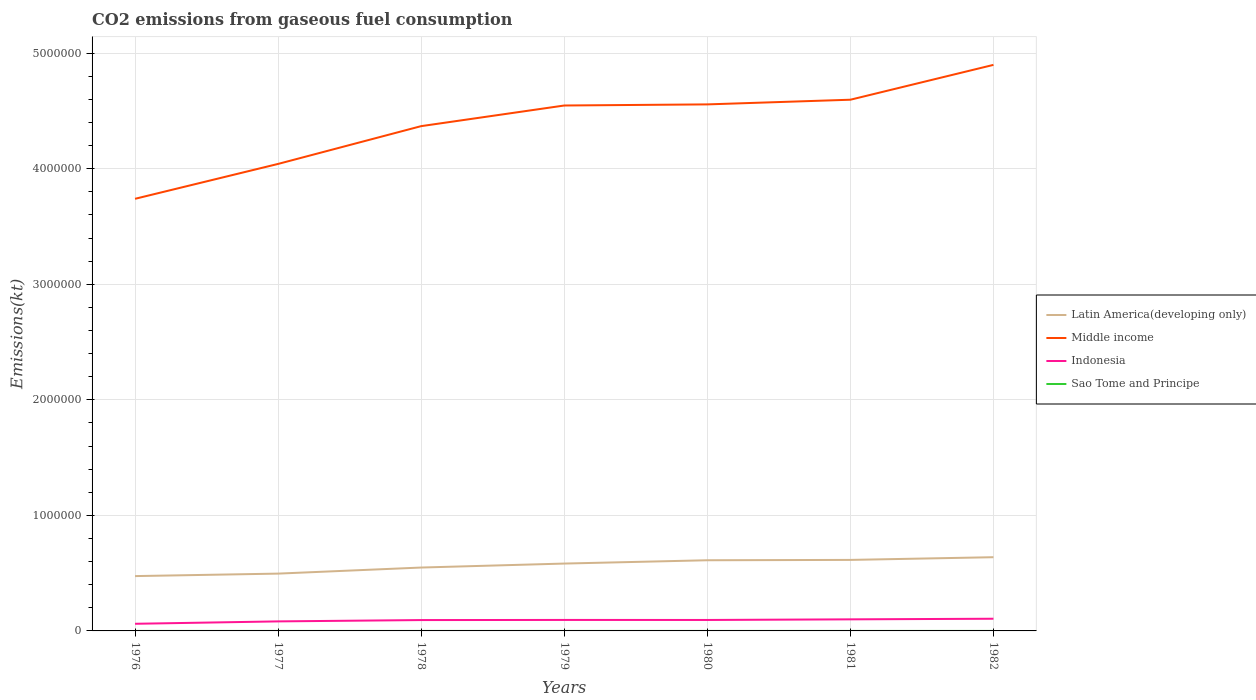How many different coloured lines are there?
Provide a short and direct response. 4. Is the number of lines equal to the number of legend labels?
Provide a succinct answer. Yes. Across all years, what is the maximum amount of CO2 emitted in Sao Tome and Principe?
Your answer should be very brief. 29.34. In which year was the amount of CO2 emitted in Sao Tome and Principe maximum?
Your response must be concise. 1976. What is the total amount of CO2 emitted in Middle income in the graph?
Offer a terse response. -1.16e+06. What is the difference between the highest and the second highest amount of CO2 emitted in Indonesia?
Your response must be concise. 4.36e+04. What is the difference between the highest and the lowest amount of CO2 emitted in Indonesia?
Your answer should be very brief. 5. Is the amount of CO2 emitted in Latin America(developing only) strictly greater than the amount of CO2 emitted in Sao Tome and Principe over the years?
Your answer should be very brief. No. How many lines are there?
Provide a succinct answer. 4. How many years are there in the graph?
Your response must be concise. 7. What is the difference between two consecutive major ticks on the Y-axis?
Make the answer very short. 1.00e+06. Are the values on the major ticks of Y-axis written in scientific E-notation?
Provide a succinct answer. No. Does the graph contain grids?
Keep it short and to the point. Yes. What is the title of the graph?
Offer a very short reply. CO2 emissions from gaseous fuel consumption. Does "Uruguay" appear as one of the legend labels in the graph?
Your response must be concise. No. What is the label or title of the X-axis?
Your answer should be very brief. Years. What is the label or title of the Y-axis?
Provide a short and direct response. Emissions(kt). What is the Emissions(kt) of Latin America(developing only) in 1976?
Provide a short and direct response. 4.74e+05. What is the Emissions(kt) in Middle income in 1976?
Ensure brevity in your answer.  3.74e+06. What is the Emissions(kt) in Indonesia in 1976?
Make the answer very short. 6.18e+04. What is the Emissions(kt) in Sao Tome and Principe in 1976?
Your response must be concise. 29.34. What is the Emissions(kt) of Latin America(developing only) in 1977?
Ensure brevity in your answer.  4.96e+05. What is the Emissions(kt) in Middle income in 1977?
Offer a terse response. 4.04e+06. What is the Emissions(kt) in Indonesia in 1977?
Your answer should be compact. 8.24e+04. What is the Emissions(kt) in Sao Tome and Principe in 1977?
Your answer should be compact. 29.34. What is the Emissions(kt) in Latin America(developing only) in 1978?
Make the answer very short. 5.49e+05. What is the Emissions(kt) of Middle income in 1978?
Keep it short and to the point. 4.37e+06. What is the Emissions(kt) of Indonesia in 1978?
Keep it short and to the point. 9.39e+04. What is the Emissions(kt) of Sao Tome and Principe in 1978?
Your answer should be very brief. 33. What is the Emissions(kt) in Latin America(developing only) in 1979?
Provide a succinct answer. 5.83e+05. What is the Emissions(kt) of Middle income in 1979?
Offer a very short reply. 4.55e+06. What is the Emissions(kt) in Indonesia in 1979?
Provide a short and direct response. 9.51e+04. What is the Emissions(kt) in Sao Tome and Principe in 1979?
Offer a very short reply. 33. What is the Emissions(kt) in Latin America(developing only) in 1980?
Make the answer very short. 6.12e+05. What is the Emissions(kt) of Middle income in 1980?
Offer a terse response. 4.56e+06. What is the Emissions(kt) in Indonesia in 1980?
Ensure brevity in your answer.  9.48e+04. What is the Emissions(kt) in Sao Tome and Principe in 1980?
Provide a succinct answer. 40.34. What is the Emissions(kt) of Latin America(developing only) in 1981?
Provide a succinct answer. 6.15e+05. What is the Emissions(kt) in Middle income in 1981?
Ensure brevity in your answer.  4.60e+06. What is the Emissions(kt) in Indonesia in 1981?
Offer a very short reply. 1.00e+05. What is the Emissions(kt) of Sao Tome and Principe in 1981?
Offer a terse response. 44. What is the Emissions(kt) in Latin America(developing only) in 1982?
Ensure brevity in your answer.  6.38e+05. What is the Emissions(kt) in Middle income in 1982?
Your response must be concise. 4.90e+06. What is the Emissions(kt) of Indonesia in 1982?
Your response must be concise. 1.05e+05. What is the Emissions(kt) of Sao Tome and Principe in 1982?
Keep it short and to the point. 47.67. Across all years, what is the maximum Emissions(kt) in Latin America(developing only)?
Your answer should be very brief. 6.38e+05. Across all years, what is the maximum Emissions(kt) of Middle income?
Ensure brevity in your answer.  4.90e+06. Across all years, what is the maximum Emissions(kt) in Indonesia?
Give a very brief answer. 1.05e+05. Across all years, what is the maximum Emissions(kt) in Sao Tome and Principe?
Offer a very short reply. 47.67. Across all years, what is the minimum Emissions(kt) of Latin America(developing only)?
Offer a very short reply. 4.74e+05. Across all years, what is the minimum Emissions(kt) in Middle income?
Keep it short and to the point. 3.74e+06. Across all years, what is the minimum Emissions(kt) in Indonesia?
Provide a short and direct response. 6.18e+04. Across all years, what is the minimum Emissions(kt) of Sao Tome and Principe?
Keep it short and to the point. 29.34. What is the total Emissions(kt) of Latin America(developing only) in the graph?
Your response must be concise. 3.97e+06. What is the total Emissions(kt) of Middle income in the graph?
Your answer should be very brief. 3.07e+07. What is the total Emissions(kt) in Indonesia in the graph?
Keep it short and to the point. 6.34e+05. What is the total Emissions(kt) of Sao Tome and Principe in the graph?
Make the answer very short. 256.69. What is the difference between the Emissions(kt) of Latin America(developing only) in 1976 and that in 1977?
Ensure brevity in your answer.  -2.16e+04. What is the difference between the Emissions(kt) of Middle income in 1976 and that in 1977?
Offer a terse response. -3.02e+05. What is the difference between the Emissions(kt) in Indonesia in 1976 and that in 1977?
Your answer should be very brief. -2.06e+04. What is the difference between the Emissions(kt) of Latin America(developing only) in 1976 and that in 1978?
Ensure brevity in your answer.  -7.41e+04. What is the difference between the Emissions(kt) of Middle income in 1976 and that in 1978?
Keep it short and to the point. -6.29e+05. What is the difference between the Emissions(kt) of Indonesia in 1976 and that in 1978?
Your answer should be compact. -3.21e+04. What is the difference between the Emissions(kt) in Sao Tome and Principe in 1976 and that in 1978?
Offer a very short reply. -3.67. What is the difference between the Emissions(kt) in Latin America(developing only) in 1976 and that in 1979?
Your response must be concise. -1.09e+05. What is the difference between the Emissions(kt) in Middle income in 1976 and that in 1979?
Your response must be concise. -8.07e+05. What is the difference between the Emissions(kt) in Indonesia in 1976 and that in 1979?
Provide a succinct answer. -3.33e+04. What is the difference between the Emissions(kt) of Sao Tome and Principe in 1976 and that in 1979?
Ensure brevity in your answer.  -3.67. What is the difference between the Emissions(kt) of Latin America(developing only) in 1976 and that in 1980?
Ensure brevity in your answer.  -1.37e+05. What is the difference between the Emissions(kt) of Middle income in 1976 and that in 1980?
Offer a very short reply. -8.17e+05. What is the difference between the Emissions(kt) in Indonesia in 1976 and that in 1980?
Your response must be concise. -3.30e+04. What is the difference between the Emissions(kt) of Sao Tome and Principe in 1976 and that in 1980?
Your response must be concise. -11. What is the difference between the Emissions(kt) in Latin America(developing only) in 1976 and that in 1981?
Keep it short and to the point. -1.40e+05. What is the difference between the Emissions(kt) in Middle income in 1976 and that in 1981?
Offer a terse response. -8.57e+05. What is the difference between the Emissions(kt) in Indonesia in 1976 and that in 1981?
Give a very brief answer. -3.83e+04. What is the difference between the Emissions(kt) in Sao Tome and Principe in 1976 and that in 1981?
Your response must be concise. -14.67. What is the difference between the Emissions(kt) in Latin America(developing only) in 1976 and that in 1982?
Your response must be concise. -1.64e+05. What is the difference between the Emissions(kt) in Middle income in 1976 and that in 1982?
Your response must be concise. -1.16e+06. What is the difference between the Emissions(kt) of Indonesia in 1976 and that in 1982?
Give a very brief answer. -4.36e+04. What is the difference between the Emissions(kt) in Sao Tome and Principe in 1976 and that in 1982?
Your answer should be compact. -18.34. What is the difference between the Emissions(kt) of Latin America(developing only) in 1977 and that in 1978?
Make the answer very short. -5.25e+04. What is the difference between the Emissions(kt) in Middle income in 1977 and that in 1978?
Keep it short and to the point. -3.27e+05. What is the difference between the Emissions(kt) in Indonesia in 1977 and that in 1978?
Offer a terse response. -1.15e+04. What is the difference between the Emissions(kt) in Sao Tome and Principe in 1977 and that in 1978?
Make the answer very short. -3.67. What is the difference between the Emissions(kt) in Latin America(developing only) in 1977 and that in 1979?
Make the answer very short. -8.70e+04. What is the difference between the Emissions(kt) in Middle income in 1977 and that in 1979?
Ensure brevity in your answer.  -5.06e+05. What is the difference between the Emissions(kt) in Indonesia in 1977 and that in 1979?
Give a very brief answer. -1.27e+04. What is the difference between the Emissions(kt) in Sao Tome and Principe in 1977 and that in 1979?
Make the answer very short. -3.67. What is the difference between the Emissions(kt) in Latin America(developing only) in 1977 and that in 1980?
Offer a terse response. -1.16e+05. What is the difference between the Emissions(kt) of Middle income in 1977 and that in 1980?
Provide a succinct answer. -5.15e+05. What is the difference between the Emissions(kt) of Indonesia in 1977 and that in 1980?
Your answer should be very brief. -1.24e+04. What is the difference between the Emissions(kt) of Sao Tome and Principe in 1977 and that in 1980?
Make the answer very short. -11. What is the difference between the Emissions(kt) of Latin America(developing only) in 1977 and that in 1981?
Your answer should be compact. -1.19e+05. What is the difference between the Emissions(kt) in Middle income in 1977 and that in 1981?
Make the answer very short. -5.56e+05. What is the difference between the Emissions(kt) of Indonesia in 1977 and that in 1981?
Offer a terse response. -1.77e+04. What is the difference between the Emissions(kt) of Sao Tome and Principe in 1977 and that in 1981?
Your response must be concise. -14.67. What is the difference between the Emissions(kt) in Latin America(developing only) in 1977 and that in 1982?
Your answer should be compact. -1.42e+05. What is the difference between the Emissions(kt) in Middle income in 1977 and that in 1982?
Ensure brevity in your answer.  -8.57e+05. What is the difference between the Emissions(kt) of Indonesia in 1977 and that in 1982?
Your response must be concise. -2.30e+04. What is the difference between the Emissions(kt) of Sao Tome and Principe in 1977 and that in 1982?
Provide a short and direct response. -18.34. What is the difference between the Emissions(kt) in Latin America(developing only) in 1978 and that in 1979?
Ensure brevity in your answer.  -3.45e+04. What is the difference between the Emissions(kt) of Middle income in 1978 and that in 1979?
Make the answer very short. -1.79e+05. What is the difference between the Emissions(kt) in Indonesia in 1978 and that in 1979?
Provide a succinct answer. -1162.44. What is the difference between the Emissions(kt) of Latin America(developing only) in 1978 and that in 1980?
Offer a very short reply. -6.31e+04. What is the difference between the Emissions(kt) in Middle income in 1978 and that in 1980?
Your response must be concise. -1.88e+05. What is the difference between the Emissions(kt) in Indonesia in 1978 and that in 1980?
Your answer should be very brief. -850.74. What is the difference between the Emissions(kt) in Sao Tome and Principe in 1978 and that in 1980?
Offer a terse response. -7.33. What is the difference between the Emissions(kt) of Latin America(developing only) in 1978 and that in 1981?
Offer a very short reply. -6.60e+04. What is the difference between the Emissions(kt) in Middle income in 1978 and that in 1981?
Offer a very short reply. -2.29e+05. What is the difference between the Emissions(kt) in Indonesia in 1978 and that in 1981?
Your answer should be very brief. -6226.57. What is the difference between the Emissions(kt) of Sao Tome and Principe in 1978 and that in 1981?
Provide a succinct answer. -11. What is the difference between the Emissions(kt) in Latin America(developing only) in 1978 and that in 1982?
Offer a very short reply. -8.94e+04. What is the difference between the Emissions(kt) of Middle income in 1978 and that in 1982?
Your response must be concise. -5.30e+05. What is the difference between the Emissions(kt) in Indonesia in 1978 and that in 1982?
Your answer should be very brief. -1.15e+04. What is the difference between the Emissions(kt) of Sao Tome and Principe in 1978 and that in 1982?
Give a very brief answer. -14.67. What is the difference between the Emissions(kt) in Latin America(developing only) in 1979 and that in 1980?
Keep it short and to the point. -2.86e+04. What is the difference between the Emissions(kt) of Middle income in 1979 and that in 1980?
Give a very brief answer. -9617.95. What is the difference between the Emissions(kt) of Indonesia in 1979 and that in 1980?
Your response must be concise. 311.69. What is the difference between the Emissions(kt) of Sao Tome and Principe in 1979 and that in 1980?
Keep it short and to the point. -7.33. What is the difference between the Emissions(kt) of Latin America(developing only) in 1979 and that in 1981?
Keep it short and to the point. -3.15e+04. What is the difference between the Emissions(kt) in Middle income in 1979 and that in 1981?
Offer a terse response. -5.00e+04. What is the difference between the Emissions(kt) of Indonesia in 1979 and that in 1981?
Give a very brief answer. -5064.13. What is the difference between the Emissions(kt) of Sao Tome and Principe in 1979 and that in 1981?
Your answer should be very brief. -11. What is the difference between the Emissions(kt) of Latin America(developing only) in 1979 and that in 1982?
Make the answer very short. -5.49e+04. What is the difference between the Emissions(kt) in Middle income in 1979 and that in 1982?
Offer a terse response. -3.52e+05. What is the difference between the Emissions(kt) of Indonesia in 1979 and that in 1982?
Offer a very short reply. -1.03e+04. What is the difference between the Emissions(kt) in Sao Tome and Principe in 1979 and that in 1982?
Your answer should be compact. -14.67. What is the difference between the Emissions(kt) of Latin America(developing only) in 1980 and that in 1981?
Your response must be concise. -2893.26. What is the difference between the Emissions(kt) in Middle income in 1980 and that in 1981?
Your answer should be very brief. -4.04e+04. What is the difference between the Emissions(kt) of Indonesia in 1980 and that in 1981?
Provide a short and direct response. -5375.82. What is the difference between the Emissions(kt) of Sao Tome and Principe in 1980 and that in 1981?
Give a very brief answer. -3.67. What is the difference between the Emissions(kt) in Latin America(developing only) in 1980 and that in 1982?
Your answer should be very brief. -2.63e+04. What is the difference between the Emissions(kt) in Middle income in 1980 and that in 1982?
Keep it short and to the point. -3.42e+05. What is the difference between the Emissions(kt) of Indonesia in 1980 and that in 1982?
Ensure brevity in your answer.  -1.06e+04. What is the difference between the Emissions(kt) in Sao Tome and Principe in 1980 and that in 1982?
Provide a short and direct response. -7.33. What is the difference between the Emissions(kt) of Latin America(developing only) in 1981 and that in 1982?
Make the answer very short. -2.34e+04. What is the difference between the Emissions(kt) in Middle income in 1981 and that in 1982?
Your answer should be compact. -3.02e+05. What is the difference between the Emissions(kt) in Indonesia in 1981 and that in 1982?
Give a very brief answer. -5247.48. What is the difference between the Emissions(kt) in Sao Tome and Principe in 1981 and that in 1982?
Provide a succinct answer. -3.67. What is the difference between the Emissions(kt) of Latin America(developing only) in 1976 and the Emissions(kt) of Middle income in 1977?
Make the answer very short. -3.57e+06. What is the difference between the Emissions(kt) of Latin America(developing only) in 1976 and the Emissions(kt) of Indonesia in 1977?
Give a very brief answer. 3.92e+05. What is the difference between the Emissions(kt) in Latin America(developing only) in 1976 and the Emissions(kt) in Sao Tome and Principe in 1977?
Ensure brevity in your answer.  4.74e+05. What is the difference between the Emissions(kt) in Middle income in 1976 and the Emissions(kt) in Indonesia in 1977?
Give a very brief answer. 3.66e+06. What is the difference between the Emissions(kt) in Middle income in 1976 and the Emissions(kt) in Sao Tome and Principe in 1977?
Your answer should be very brief. 3.74e+06. What is the difference between the Emissions(kt) in Indonesia in 1976 and the Emissions(kt) in Sao Tome and Principe in 1977?
Keep it short and to the point. 6.18e+04. What is the difference between the Emissions(kt) in Latin America(developing only) in 1976 and the Emissions(kt) in Middle income in 1978?
Offer a terse response. -3.89e+06. What is the difference between the Emissions(kt) in Latin America(developing only) in 1976 and the Emissions(kt) in Indonesia in 1978?
Give a very brief answer. 3.80e+05. What is the difference between the Emissions(kt) of Latin America(developing only) in 1976 and the Emissions(kt) of Sao Tome and Principe in 1978?
Provide a short and direct response. 4.74e+05. What is the difference between the Emissions(kt) in Middle income in 1976 and the Emissions(kt) in Indonesia in 1978?
Offer a terse response. 3.65e+06. What is the difference between the Emissions(kt) of Middle income in 1976 and the Emissions(kt) of Sao Tome and Principe in 1978?
Offer a terse response. 3.74e+06. What is the difference between the Emissions(kt) in Indonesia in 1976 and the Emissions(kt) in Sao Tome and Principe in 1978?
Keep it short and to the point. 6.18e+04. What is the difference between the Emissions(kt) in Latin America(developing only) in 1976 and the Emissions(kt) in Middle income in 1979?
Give a very brief answer. -4.07e+06. What is the difference between the Emissions(kt) in Latin America(developing only) in 1976 and the Emissions(kt) in Indonesia in 1979?
Offer a very short reply. 3.79e+05. What is the difference between the Emissions(kt) of Latin America(developing only) in 1976 and the Emissions(kt) of Sao Tome and Principe in 1979?
Offer a very short reply. 4.74e+05. What is the difference between the Emissions(kt) of Middle income in 1976 and the Emissions(kt) of Indonesia in 1979?
Provide a succinct answer. 3.64e+06. What is the difference between the Emissions(kt) of Middle income in 1976 and the Emissions(kt) of Sao Tome and Principe in 1979?
Your response must be concise. 3.74e+06. What is the difference between the Emissions(kt) of Indonesia in 1976 and the Emissions(kt) of Sao Tome and Principe in 1979?
Give a very brief answer. 6.18e+04. What is the difference between the Emissions(kt) in Latin America(developing only) in 1976 and the Emissions(kt) in Middle income in 1980?
Provide a short and direct response. -4.08e+06. What is the difference between the Emissions(kt) in Latin America(developing only) in 1976 and the Emissions(kt) in Indonesia in 1980?
Give a very brief answer. 3.80e+05. What is the difference between the Emissions(kt) in Latin America(developing only) in 1976 and the Emissions(kt) in Sao Tome and Principe in 1980?
Your response must be concise. 4.74e+05. What is the difference between the Emissions(kt) of Middle income in 1976 and the Emissions(kt) of Indonesia in 1980?
Make the answer very short. 3.64e+06. What is the difference between the Emissions(kt) in Middle income in 1976 and the Emissions(kt) in Sao Tome and Principe in 1980?
Ensure brevity in your answer.  3.74e+06. What is the difference between the Emissions(kt) in Indonesia in 1976 and the Emissions(kt) in Sao Tome and Principe in 1980?
Provide a succinct answer. 6.18e+04. What is the difference between the Emissions(kt) in Latin America(developing only) in 1976 and the Emissions(kt) in Middle income in 1981?
Offer a very short reply. -4.12e+06. What is the difference between the Emissions(kt) of Latin America(developing only) in 1976 and the Emissions(kt) of Indonesia in 1981?
Provide a succinct answer. 3.74e+05. What is the difference between the Emissions(kt) of Latin America(developing only) in 1976 and the Emissions(kt) of Sao Tome and Principe in 1981?
Ensure brevity in your answer.  4.74e+05. What is the difference between the Emissions(kt) in Middle income in 1976 and the Emissions(kt) in Indonesia in 1981?
Keep it short and to the point. 3.64e+06. What is the difference between the Emissions(kt) of Middle income in 1976 and the Emissions(kt) of Sao Tome and Principe in 1981?
Your response must be concise. 3.74e+06. What is the difference between the Emissions(kt) in Indonesia in 1976 and the Emissions(kt) in Sao Tome and Principe in 1981?
Offer a very short reply. 6.18e+04. What is the difference between the Emissions(kt) in Latin America(developing only) in 1976 and the Emissions(kt) in Middle income in 1982?
Keep it short and to the point. -4.42e+06. What is the difference between the Emissions(kt) of Latin America(developing only) in 1976 and the Emissions(kt) of Indonesia in 1982?
Ensure brevity in your answer.  3.69e+05. What is the difference between the Emissions(kt) of Latin America(developing only) in 1976 and the Emissions(kt) of Sao Tome and Principe in 1982?
Give a very brief answer. 4.74e+05. What is the difference between the Emissions(kt) in Middle income in 1976 and the Emissions(kt) in Indonesia in 1982?
Your answer should be very brief. 3.63e+06. What is the difference between the Emissions(kt) in Middle income in 1976 and the Emissions(kt) in Sao Tome and Principe in 1982?
Provide a short and direct response. 3.74e+06. What is the difference between the Emissions(kt) of Indonesia in 1976 and the Emissions(kt) of Sao Tome and Principe in 1982?
Offer a terse response. 6.18e+04. What is the difference between the Emissions(kt) of Latin America(developing only) in 1977 and the Emissions(kt) of Middle income in 1978?
Your answer should be very brief. -3.87e+06. What is the difference between the Emissions(kt) in Latin America(developing only) in 1977 and the Emissions(kt) in Indonesia in 1978?
Keep it short and to the point. 4.02e+05. What is the difference between the Emissions(kt) in Latin America(developing only) in 1977 and the Emissions(kt) in Sao Tome and Principe in 1978?
Your response must be concise. 4.96e+05. What is the difference between the Emissions(kt) of Middle income in 1977 and the Emissions(kt) of Indonesia in 1978?
Offer a terse response. 3.95e+06. What is the difference between the Emissions(kt) in Middle income in 1977 and the Emissions(kt) in Sao Tome and Principe in 1978?
Give a very brief answer. 4.04e+06. What is the difference between the Emissions(kt) in Indonesia in 1977 and the Emissions(kt) in Sao Tome and Principe in 1978?
Your answer should be compact. 8.24e+04. What is the difference between the Emissions(kt) of Latin America(developing only) in 1977 and the Emissions(kt) of Middle income in 1979?
Ensure brevity in your answer.  -4.05e+06. What is the difference between the Emissions(kt) in Latin America(developing only) in 1977 and the Emissions(kt) in Indonesia in 1979?
Offer a very short reply. 4.01e+05. What is the difference between the Emissions(kt) of Latin America(developing only) in 1977 and the Emissions(kt) of Sao Tome and Principe in 1979?
Your answer should be compact. 4.96e+05. What is the difference between the Emissions(kt) of Middle income in 1977 and the Emissions(kt) of Indonesia in 1979?
Make the answer very short. 3.95e+06. What is the difference between the Emissions(kt) of Middle income in 1977 and the Emissions(kt) of Sao Tome and Principe in 1979?
Your answer should be compact. 4.04e+06. What is the difference between the Emissions(kt) in Indonesia in 1977 and the Emissions(kt) in Sao Tome and Principe in 1979?
Your response must be concise. 8.24e+04. What is the difference between the Emissions(kt) of Latin America(developing only) in 1977 and the Emissions(kt) of Middle income in 1980?
Your answer should be compact. -4.06e+06. What is the difference between the Emissions(kt) of Latin America(developing only) in 1977 and the Emissions(kt) of Indonesia in 1980?
Your response must be concise. 4.01e+05. What is the difference between the Emissions(kt) of Latin America(developing only) in 1977 and the Emissions(kt) of Sao Tome and Principe in 1980?
Give a very brief answer. 4.96e+05. What is the difference between the Emissions(kt) in Middle income in 1977 and the Emissions(kt) in Indonesia in 1980?
Provide a short and direct response. 3.95e+06. What is the difference between the Emissions(kt) of Middle income in 1977 and the Emissions(kt) of Sao Tome and Principe in 1980?
Provide a short and direct response. 4.04e+06. What is the difference between the Emissions(kt) of Indonesia in 1977 and the Emissions(kt) of Sao Tome and Principe in 1980?
Ensure brevity in your answer.  8.24e+04. What is the difference between the Emissions(kt) of Latin America(developing only) in 1977 and the Emissions(kt) of Middle income in 1981?
Provide a short and direct response. -4.10e+06. What is the difference between the Emissions(kt) of Latin America(developing only) in 1977 and the Emissions(kt) of Indonesia in 1981?
Your answer should be compact. 3.96e+05. What is the difference between the Emissions(kt) of Latin America(developing only) in 1977 and the Emissions(kt) of Sao Tome and Principe in 1981?
Give a very brief answer. 4.96e+05. What is the difference between the Emissions(kt) of Middle income in 1977 and the Emissions(kt) of Indonesia in 1981?
Offer a terse response. 3.94e+06. What is the difference between the Emissions(kt) of Middle income in 1977 and the Emissions(kt) of Sao Tome and Principe in 1981?
Provide a succinct answer. 4.04e+06. What is the difference between the Emissions(kt) in Indonesia in 1977 and the Emissions(kt) in Sao Tome and Principe in 1981?
Provide a succinct answer. 8.24e+04. What is the difference between the Emissions(kt) of Latin America(developing only) in 1977 and the Emissions(kt) of Middle income in 1982?
Provide a succinct answer. -4.40e+06. What is the difference between the Emissions(kt) of Latin America(developing only) in 1977 and the Emissions(kt) of Indonesia in 1982?
Offer a terse response. 3.91e+05. What is the difference between the Emissions(kt) of Latin America(developing only) in 1977 and the Emissions(kt) of Sao Tome and Principe in 1982?
Make the answer very short. 4.96e+05. What is the difference between the Emissions(kt) in Middle income in 1977 and the Emissions(kt) in Indonesia in 1982?
Your answer should be compact. 3.94e+06. What is the difference between the Emissions(kt) of Middle income in 1977 and the Emissions(kt) of Sao Tome and Principe in 1982?
Your response must be concise. 4.04e+06. What is the difference between the Emissions(kt) of Indonesia in 1977 and the Emissions(kt) of Sao Tome and Principe in 1982?
Offer a very short reply. 8.24e+04. What is the difference between the Emissions(kt) of Latin America(developing only) in 1978 and the Emissions(kt) of Middle income in 1979?
Keep it short and to the point. -4.00e+06. What is the difference between the Emissions(kt) of Latin America(developing only) in 1978 and the Emissions(kt) of Indonesia in 1979?
Your answer should be very brief. 4.53e+05. What is the difference between the Emissions(kt) in Latin America(developing only) in 1978 and the Emissions(kt) in Sao Tome and Principe in 1979?
Give a very brief answer. 5.48e+05. What is the difference between the Emissions(kt) in Middle income in 1978 and the Emissions(kt) in Indonesia in 1979?
Ensure brevity in your answer.  4.27e+06. What is the difference between the Emissions(kt) in Middle income in 1978 and the Emissions(kt) in Sao Tome and Principe in 1979?
Offer a very short reply. 4.37e+06. What is the difference between the Emissions(kt) in Indonesia in 1978 and the Emissions(kt) in Sao Tome and Principe in 1979?
Ensure brevity in your answer.  9.39e+04. What is the difference between the Emissions(kt) in Latin America(developing only) in 1978 and the Emissions(kt) in Middle income in 1980?
Give a very brief answer. -4.01e+06. What is the difference between the Emissions(kt) in Latin America(developing only) in 1978 and the Emissions(kt) in Indonesia in 1980?
Your answer should be compact. 4.54e+05. What is the difference between the Emissions(kt) of Latin America(developing only) in 1978 and the Emissions(kt) of Sao Tome and Principe in 1980?
Offer a very short reply. 5.48e+05. What is the difference between the Emissions(kt) in Middle income in 1978 and the Emissions(kt) in Indonesia in 1980?
Make the answer very short. 4.27e+06. What is the difference between the Emissions(kt) of Middle income in 1978 and the Emissions(kt) of Sao Tome and Principe in 1980?
Your answer should be compact. 4.37e+06. What is the difference between the Emissions(kt) of Indonesia in 1978 and the Emissions(kt) of Sao Tome and Principe in 1980?
Your response must be concise. 9.39e+04. What is the difference between the Emissions(kt) of Latin America(developing only) in 1978 and the Emissions(kt) of Middle income in 1981?
Offer a very short reply. -4.05e+06. What is the difference between the Emissions(kt) in Latin America(developing only) in 1978 and the Emissions(kt) in Indonesia in 1981?
Provide a succinct answer. 4.48e+05. What is the difference between the Emissions(kt) in Latin America(developing only) in 1978 and the Emissions(kt) in Sao Tome and Principe in 1981?
Provide a succinct answer. 5.48e+05. What is the difference between the Emissions(kt) in Middle income in 1978 and the Emissions(kt) in Indonesia in 1981?
Make the answer very short. 4.27e+06. What is the difference between the Emissions(kt) in Middle income in 1978 and the Emissions(kt) in Sao Tome and Principe in 1981?
Your response must be concise. 4.37e+06. What is the difference between the Emissions(kt) of Indonesia in 1978 and the Emissions(kt) of Sao Tome and Principe in 1981?
Make the answer very short. 9.39e+04. What is the difference between the Emissions(kt) in Latin America(developing only) in 1978 and the Emissions(kt) in Middle income in 1982?
Give a very brief answer. -4.35e+06. What is the difference between the Emissions(kt) in Latin America(developing only) in 1978 and the Emissions(kt) in Indonesia in 1982?
Make the answer very short. 4.43e+05. What is the difference between the Emissions(kt) in Latin America(developing only) in 1978 and the Emissions(kt) in Sao Tome and Principe in 1982?
Your answer should be compact. 5.48e+05. What is the difference between the Emissions(kt) in Middle income in 1978 and the Emissions(kt) in Indonesia in 1982?
Keep it short and to the point. 4.26e+06. What is the difference between the Emissions(kt) in Middle income in 1978 and the Emissions(kt) in Sao Tome and Principe in 1982?
Make the answer very short. 4.37e+06. What is the difference between the Emissions(kt) in Indonesia in 1978 and the Emissions(kt) in Sao Tome and Principe in 1982?
Your response must be concise. 9.39e+04. What is the difference between the Emissions(kt) of Latin America(developing only) in 1979 and the Emissions(kt) of Middle income in 1980?
Ensure brevity in your answer.  -3.97e+06. What is the difference between the Emissions(kt) of Latin America(developing only) in 1979 and the Emissions(kt) of Indonesia in 1980?
Your response must be concise. 4.88e+05. What is the difference between the Emissions(kt) in Latin America(developing only) in 1979 and the Emissions(kt) in Sao Tome and Principe in 1980?
Ensure brevity in your answer.  5.83e+05. What is the difference between the Emissions(kt) of Middle income in 1979 and the Emissions(kt) of Indonesia in 1980?
Provide a succinct answer. 4.45e+06. What is the difference between the Emissions(kt) in Middle income in 1979 and the Emissions(kt) in Sao Tome and Principe in 1980?
Make the answer very short. 4.55e+06. What is the difference between the Emissions(kt) of Indonesia in 1979 and the Emissions(kt) of Sao Tome and Principe in 1980?
Ensure brevity in your answer.  9.51e+04. What is the difference between the Emissions(kt) in Latin America(developing only) in 1979 and the Emissions(kt) in Middle income in 1981?
Your response must be concise. -4.01e+06. What is the difference between the Emissions(kt) of Latin America(developing only) in 1979 and the Emissions(kt) of Indonesia in 1981?
Your answer should be compact. 4.83e+05. What is the difference between the Emissions(kt) of Latin America(developing only) in 1979 and the Emissions(kt) of Sao Tome and Principe in 1981?
Your answer should be compact. 5.83e+05. What is the difference between the Emissions(kt) of Middle income in 1979 and the Emissions(kt) of Indonesia in 1981?
Your answer should be compact. 4.45e+06. What is the difference between the Emissions(kt) in Middle income in 1979 and the Emissions(kt) in Sao Tome and Principe in 1981?
Give a very brief answer. 4.55e+06. What is the difference between the Emissions(kt) of Indonesia in 1979 and the Emissions(kt) of Sao Tome and Principe in 1981?
Give a very brief answer. 9.51e+04. What is the difference between the Emissions(kt) in Latin America(developing only) in 1979 and the Emissions(kt) in Middle income in 1982?
Your answer should be compact. -4.32e+06. What is the difference between the Emissions(kt) in Latin America(developing only) in 1979 and the Emissions(kt) in Indonesia in 1982?
Offer a terse response. 4.78e+05. What is the difference between the Emissions(kt) in Latin America(developing only) in 1979 and the Emissions(kt) in Sao Tome and Principe in 1982?
Your answer should be very brief. 5.83e+05. What is the difference between the Emissions(kt) in Middle income in 1979 and the Emissions(kt) in Indonesia in 1982?
Your answer should be compact. 4.44e+06. What is the difference between the Emissions(kt) in Middle income in 1979 and the Emissions(kt) in Sao Tome and Principe in 1982?
Provide a succinct answer. 4.55e+06. What is the difference between the Emissions(kt) of Indonesia in 1979 and the Emissions(kt) of Sao Tome and Principe in 1982?
Your response must be concise. 9.50e+04. What is the difference between the Emissions(kt) of Latin America(developing only) in 1980 and the Emissions(kt) of Middle income in 1981?
Your answer should be very brief. -3.99e+06. What is the difference between the Emissions(kt) in Latin America(developing only) in 1980 and the Emissions(kt) in Indonesia in 1981?
Your response must be concise. 5.11e+05. What is the difference between the Emissions(kt) in Latin America(developing only) in 1980 and the Emissions(kt) in Sao Tome and Principe in 1981?
Offer a very short reply. 6.12e+05. What is the difference between the Emissions(kt) of Middle income in 1980 and the Emissions(kt) of Indonesia in 1981?
Provide a short and direct response. 4.46e+06. What is the difference between the Emissions(kt) of Middle income in 1980 and the Emissions(kt) of Sao Tome and Principe in 1981?
Make the answer very short. 4.56e+06. What is the difference between the Emissions(kt) of Indonesia in 1980 and the Emissions(kt) of Sao Tome and Principe in 1981?
Provide a succinct answer. 9.47e+04. What is the difference between the Emissions(kt) in Latin America(developing only) in 1980 and the Emissions(kt) in Middle income in 1982?
Provide a short and direct response. -4.29e+06. What is the difference between the Emissions(kt) of Latin America(developing only) in 1980 and the Emissions(kt) of Indonesia in 1982?
Offer a very short reply. 5.06e+05. What is the difference between the Emissions(kt) of Latin America(developing only) in 1980 and the Emissions(kt) of Sao Tome and Principe in 1982?
Offer a terse response. 6.12e+05. What is the difference between the Emissions(kt) of Middle income in 1980 and the Emissions(kt) of Indonesia in 1982?
Ensure brevity in your answer.  4.45e+06. What is the difference between the Emissions(kt) in Middle income in 1980 and the Emissions(kt) in Sao Tome and Principe in 1982?
Offer a very short reply. 4.56e+06. What is the difference between the Emissions(kt) of Indonesia in 1980 and the Emissions(kt) of Sao Tome and Principe in 1982?
Your answer should be very brief. 9.47e+04. What is the difference between the Emissions(kt) of Latin America(developing only) in 1981 and the Emissions(kt) of Middle income in 1982?
Keep it short and to the point. -4.28e+06. What is the difference between the Emissions(kt) in Latin America(developing only) in 1981 and the Emissions(kt) in Indonesia in 1982?
Make the answer very short. 5.09e+05. What is the difference between the Emissions(kt) in Latin America(developing only) in 1981 and the Emissions(kt) in Sao Tome and Principe in 1982?
Ensure brevity in your answer.  6.14e+05. What is the difference between the Emissions(kt) in Middle income in 1981 and the Emissions(kt) in Indonesia in 1982?
Provide a succinct answer. 4.49e+06. What is the difference between the Emissions(kt) of Middle income in 1981 and the Emissions(kt) of Sao Tome and Principe in 1982?
Offer a very short reply. 4.60e+06. What is the difference between the Emissions(kt) of Indonesia in 1981 and the Emissions(kt) of Sao Tome and Principe in 1982?
Provide a short and direct response. 1.00e+05. What is the average Emissions(kt) of Latin America(developing only) per year?
Your answer should be very brief. 5.67e+05. What is the average Emissions(kt) in Middle income per year?
Give a very brief answer. 4.39e+06. What is the average Emissions(kt) in Indonesia per year?
Offer a very short reply. 9.05e+04. What is the average Emissions(kt) of Sao Tome and Principe per year?
Offer a very short reply. 36.67. In the year 1976, what is the difference between the Emissions(kt) in Latin America(developing only) and Emissions(kt) in Middle income?
Your response must be concise. -3.27e+06. In the year 1976, what is the difference between the Emissions(kt) in Latin America(developing only) and Emissions(kt) in Indonesia?
Provide a succinct answer. 4.13e+05. In the year 1976, what is the difference between the Emissions(kt) in Latin America(developing only) and Emissions(kt) in Sao Tome and Principe?
Provide a short and direct response. 4.74e+05. In the year 1976, what is the difference between the Emissions(kt) in Middle income and Emissions(kt) in Indonesia?
Provide a short and direct response. 3.68e+06. In the year 1976, what is the difference between the Emissions(kt) in Middle income and Emissions(kt) in Sao Tome and Principe?
Provide a short and direct response. 3.74e+06. In the year 1976, what is the difference between the Emissions(kt) of Indonesia and Emissions(kt) of Sao Tome and Principe?
Provide a succinct answer. 6.18e+04. In the year 1977, what is the difference between the Emissions(kt) in Latin America(developing only) and Emissions(kt) in Middle income?
Ensure brevity in your answer.  -3.55e+06. In the year 1977, what is the difference between the Emissions(kt) in Latin America(developing only) and Emissions(kt) in Indonesia?
Ensure brevity in your answer.  4.14e+05. In the year 1977, what is the difference between the Emissions(kt) in Latin America(developing only) and Emissions(kt) in Sao Tome and Principe?
Keep it short and to the point. 4.96e+05. In the year 1977, what is the difference between the Emissions(kt) in Middle income and Emissions(kt) in Indonesia?
Give a very brief answer. 3.96e+06. In the year 1977, what is the difference between the Emissions(kt) of Middle income and Emissions(kt) of Sao Tome and Principe?
Provide a short and direct response. 4.04e+06. In the year 1977, what is the difference between the Emissions(kt) in Indonesia and Emissions(kt) in Sao Tome and Principe?
Keep it short and to the point. 8.24e+04. In the year 1978, what is the difference between the Emissions(kt) in Latin America(developing only) and Emissions(kt) in Middle income?
Provide a succinct answer. -3.82e+06. In the year 1978, what is the difference between the Emissions(kt) of Latin America(developing only) and Emissions(kt) of Indonesia?
Your answer should be compact. 4.55e+05. In the year 1978, what is the difference between the Emissions(kt) of Latin America(developing only) and Emissions(kt) of Sao Tome and Principe?
Ensure brevity in your answer.  5.48e+05. In the year 1978, what is the difference between the Emissions(kt) in Middle income and Emissions(kt) in Indonesia?
Offer a terse response. 4.27e+06. In the year 1978, what is the difference between the Emissions(kt) of Middle income and Emissions(kt) of Sao Tome and Principe?
Provide a succinct answer. 4.37e+06. In the year 1978, what is the difference between the Emissions(kt) in Indonesia and Emissions(kt) in Sao Tome and Principe?
Provide a short and direct response. 9.39e+04. In the year 1979, what is the difference between the Emissions(kt) of Latin America(developing only) and Emissions(kt) of Middle income?
Provide a succinct answer. -3.96e+06. In the year 1979, what is the difference between the Emissions(kt) of Latin America(developing only) and Emissions(kt) of Indonesia?
Keep it short and to the point. 4.88e+05. In the year 1979, what is the difference between the Emissions(kt) in Latin America(developing only) and Emissions(kt) in Sao Tome and Principe?
Ensure brevity in your answer.  5.83e+05. In the year 1979, what is the difference between the Emissions(kt) in Middle income and Emissions(kt) in Indonesia?
Provide a short and direct response. 4.45e+06. In the year 1979, what is the difference between the Emissions(kt) of Middle income and Emissions(kt) of Sao Tome and Principe?
Your answer should be very brief. 4.55e+06. In the year 1979, what is the difference between the Emissions(kt) in Indonesia and Emissions(kt) in Sao Tome and Principe?
Provide a succinct answer. 9.51e+04. In the year 1980, what is the difference between the Emissions(kt) of Latin America(developing only) and Emissions(kt) of Middle income?
Ensure brevity in your answer.  -3.95e+06. In the year 1980, what is the difference between the Emissions(kt) in Latin America(developing only) and Emissions(kt) in Indonesia?
Offer a very short reply. 5.17e+05. In the year 1980, what is the difference between the Emissions(kt) in Latin America(developing only) and Emissions(kt) in Sao Tome and Principe?
Give a very brief answer. 6.12e+05. In the year 1980, what is the difference between the Emissions(kt) in Middle income and Emissions(kt) in Indonesia?
Ensure brevity in your answer.  4.46e+06. In the year 1980, what is the difference between the Emissions(kt) of Middle income and Emissions(kt) of Sao Tome and Principe?
Provide a succinct answer. 4.56e+06. In the year 1980, what is the difference between the Emissions(kt) in Indonesia and Emissions(kt) in Sao Tome and Principe?
Offer a very short reply. 9.47e+04. In the year 1981, what is the difference between the Emissions(kt) in Latin America(developing only) and Emissions(kt) in Middle income?
Give a very brief answer. -3.98e+06. In the year 1981, what is the difference between the Emissions(kt) in Latin America(developing only) and Emissions(kt) in Indonesia?
Provide a succinct answer. 5.14e+05. In the year 1981, what is the difference between the Emissions(kt) in Latin America(developing only) and Emissions(kt) in Sao Tome and Principe?
Ensure brevity in your answer.  6.14e+05. In the year 1981, what is the difference between the Emissions(kt) of Middle income and Emissions(kt) of Indonesia?
Give a very brief answer. 4.50e+06. In the year 1981, what is the difference between the Emissions(kt) of Middle income and Emissions(kt) of Sao Tome and Principe?
Provide a short and direct response. 4.60e+06. In the year 1981, what is the difference between the Emissions(kt) in Indonesia and Emissions(kt) in Sao Tome and Principe?
Your answer should be compact. 1.00e+05. In the year 1982, what is the difference between the Emissions(kt) in Latin America(developing only) and Emissions(kt) in Middle income?
Offer a very short reply. -4.26e+06. In the year 1982, what is the difference between the Emissions(kt) of Latin America(developing only) and Emissions(kt) of Indonesia?
Your answer should be very brief. 5.33e+05. In the year 1982, what is the difference between the Emissions(kt) in Latin America(developing only) and Emissions(kt) in Sao Tome and Principe?
Offer a very short reply. 6.38e+05. In the year 1982, what is the difference between the Emissions(kt) of Middle income and Emissions(kt) of Indonesia?
Provide a succinct answer. 4.79e+06. In the year 1982, what is the difference between the Emissions(kt) in Middle income and Emissions(kt) in Sao Tome and Principe?
Give a very brief answer. 4.90e+06. In the year 1982, what is the difference between the Emissions(kt) of Indonesia and Emissions(kt) of Sao Tome and Principe?
Offer a terse response. 1.05e+05. What is the ratio of the Emissions(kt) of Latin America(developing only) in 1976 to that in 1977?
Your response must be concise. 0.96. What is the ratio of the Emissions(kt) of Middle income in 1976 to that in 1977?
Make the answer very short. 0.93. What is the ratio of the Emissions(kt) of Indonesia in 1976 to that in 1977?
Your answer should be compact. 0.75. What is the ratio of the Emissions(kt) in Sao Tome and Principe in 1976 to that in 1977?
Provide a succinct answer. 1. What is the ratio of the Emissions(kt) of Latin America(developing only) in 1976 to that in 1978?
Offer a terse response. 0.86. What is the ratio of the Emissions(kt) of Middle income in 1976 to that in 1978?
Offer a very short reply. 0.86. What is the ratio of the Emissions(kt) of Indonesia in 1976 to that in 1978?
Your response must be concise. 0.66. What is the ratio of the Emissions(kt) of Sao Tome and Principe in 1976 to that in 1978?
Your response must be concise. 0.89. What is the ratio of the Emissions(kt) in Latin America(developing only) in 1976 to that in 1979?
Provide a succinct answer. 0.81. What is the ratio of the Emissions(kt) of Middle income in 1976 to that in 1979?
Your answer should be very brief. 0.82. What is the ratio of the Emissions(kt) of Indonesia in 1976 to that in 1979?
Offer a very short reply. 0.65. What is the ratio of the Emissions(kt) of Sao Tome and Principe in 1976 to that in 1979?
Your answer should be very brief. 0.89. What is the ratio of the Emissions(kt) in Latin America(developing only) in 1976 to that in 1980?
Provide a succinct answer. 0.78. What is the ratio of the Emissions(kt) in Middle income in 1976 to that in 1980?
Ensure brevity in your answer.  0.82. What is the ratio of the Emissions(kt) in Indonesia in 1976 to that in 1980?
Your answer should be very brief. 0.65. What is the ratio of the Emissions(kt) of Sao Tome and Principe in 1976 to that in 1980?
Make the answer very short. 0.73. What is the ratio of the Emissions(kt) of Latin America(developing only) in 1976 to that in 1981?
Ensure brevity in your answer.  0.77. What is the ratio of the Emissions(kt) in Middle income in 1976 to that in 1981?
Offer a very short reply. 0.81. What is the ratio of the Emissions(kt) of Indonesia in 1976 to that in 1981?
Offer a terse response. 0.62. What is the ratio of the Emissions(kt) in Latin America(developing only) in 1976 to that in 1982?
Give a very brief answer. 0.74. What is the ratio of the Emissions(kt) in Middle income in 1976 to that in 1982?
Your answer should be very brief. 0.76. What is the ratio of the Emissions(kt) in Indonesia in 1976 to that in 1982?
Provide a short and direct response. 0.59. What is the ratio of the Emissions(kt) in Sao Tome and Principe in 1976 to that in 1982?
Provide a short and direct response. 0.62. What is the ratio of the Emissions(kt) of Latin America(developing only) in 1977 to that in 1978?
Make the answer very short. 0.9. What is the ratio of the Emissions(kt) in Middle income in 1977 to that in 1978?
Keep it short and to the point. 0.93. What is the ratio of the Emissions(kt) in Indonesia in 1977 to that in 1978?
Your answer should be very brief. 0.88. What is the ratio of the Emissions(kt) in Latin America(developing only) in 1977 to that in 1979?
Provide a short and direct response. 0.85. What is the ratio of the Emissions(kt) of Middle income in 1977 to that in 1979?
Your answer should be compact. 0.89. What is the ratio of the Emissions(kt) of Indonesia in 1977 to that in 1979?
Your response must be concise. 0.87. What is the ratio of the Emissions(kt) of Sao Tome and Principe in 1977 to that in 1979?
Keep it short and to the point. 0.89. What is the ratio of the Emissions(kt) of Latin America(developing only) in 1977 to that in 1980?
Give a very brief answer. 0.81. What is the ratio of the Emissions(kt) in Middle income in 1977 to that in 1980?
Make the answer very short. 0.89. What is the ratio of the Emissions(kt) in Indonesia in 1977 to that in 1980?
Provide a succinct answer. 0.87. What is the ratio of the Emissions(kt) of Sao Tome and Principe in 1977 to that in 1980?
Offer a terse response. 0.73. What is the ratio of the Emissions(kt) in Latin America(developing only) in 1977 to that in 1981?
Provide a short and direct response. 0.81. What is the ratio of the Emissions(kt) in Middle income in 1977 to that in 1981?
Offer a very short reply. 0.88. What is the ratio of the Emissions(kt) in Indonesia in 1977 to that in 1981?
Your answer should be very brief. 0.82. What is the ratio of the Emissions(kt) in Sao Tome and Principe in 1977 to that in 1981?
Provide a succinct answer. 0.67. What is the ratio of the Emissions(kt) of Latin America(developing only) in 1977 to that in 1982?
Ensure brevity in your answer.  0.78. What is the ratio of the Emissions(kt) of Middle income in 1977 to that in 1982?
Offer a terse response. 0.82. What is the ratio of the Emissions(kt) in Indonesia in 1977 to that in 1982?
Offer a very short reply. 0.78. What is the ratio of the Emissions(kt) of Sao Tome and Principe in 1977 to that in 1982?
Provide a short and direct response. 0.62. What is the ratio of the Emissions(kt) of Latin America(developing only) in 1978 to that in 1979?
Your answer should be compact. 0.94. What is the ratio of the Emissions(kt) of Middle income in 1978 to that in 1979?
Keep it short and to the point. 0.96. What is the ratio of the Emissions(kt) of Indonesia in 1978 to that in 1979?
Your response must be concise. 0.99. What is the ratio of the Emissions(kt) in Sao Tome and Principe in 1978 to that in 1979?
Your answer should be very brief. 1. What is the ratio of the Emissions(kt) in Latin America(developing only) in 1978 to that in 1980?
Your response must be concise. 0.9. What is the ratio of the Emissions(kt) of Middle income in 1978 to that in 1980?
Make the answer very short. 0.96. What is the ratio of the Emissions(kt) of Sao Tome and Principe in 1978 to that in 1980?
Provide a succinct answer. 0.82. What is the ratio of the Emissions(kt) of Latin America(developing only) in 1978 to that in 1981?
Ensure brevity in your answer.  0.89. What is the ratio of the Emissions(kt) in Middle income in 1978 to that in 1981?
Give a very brief answer. 0.95. What is the ratio of the Emissions(kt) in Indonesia in 1978 to that in 1981?
Offer a terse response. 0.94. What is the ratio of the Emissions(kt) in Sao Tome and Principe in 1978 to that in 1981?
Offer a very short reply. 0.75. What is the ratio of the Emissions(kt) of Latin America(developing only) in 1978 to that in 1982?
Give a very brief answer. 0.86. What is the ratio of the Emissions(kt) in Middle income in 1978 to that in 1982?
Your answer should be very brief. 0.89. What is the ratio of the Emissions(kt) in Indonesia in 1978 to that in 1982?
Offer a very short reply. 0.89. What is the ratio of the Emissions(kt) in Sao Tome and Principe in 1978 to that in 1982?
Give a very brief answer. 0.69. What is the ratio of the Emissions(kt) in Latin America(developing only) in 1979 to that in 1980?
Give a very brief answer. 0.95. What is the ratio of the Emissions(kt) in Middle income in 1979 to that in 1980?
Provide a succinct answer. 1. What is the ratio of the Emissions(kt) of Indonesia in 1979 to that in 1980?
Keep it short and to the point. 1. What is the ratio of the Emissions(kt) of Sao Tome and Principe in 1979 to that in 1980?
Make the answer very short. 0.82. What is the ratio of the Emissions(kt) in Latin America(developing only) in 1979 to that in 1981?
Provide a short and direct response. 0.95. What is the ratio of the Emissions(kt) of Indonesia in 1979 to that in 1981?
Make the answer very short. 0.95. What is the ratio of the Emissions(kt) in Sao Tome and Principe in 1979 to that in 1981?
Ensure brevity in your answer.  0.75. What is the ratio of the Emissions(kt) in Latin America(developing only) in 1979 to that in 1982?
Your response must be concise. 0.91. What is the ratio of the Emissions(kt) in Middle income in 1979 to that in 1982?
Offer a very short reply. 0.93. What is the ratio of the Emissions(kt) in Indonesia in 1979 to that in 1982?
Provide a succinct answer. 0.9. What is the ratio of the Emissions(kt) of Sao Tome and Principe in 1979 to that in 1982?
Offer a very short reply. 0.69. What is the ratio of the Emissions(kt) in Latin America(developing only) in 1980 to that in 1981?
Your response must be concise. 1. What is the ratio of the Emissions(kt) in Middle income in 1980 to that in 1981?
Provide a succinct answer. 0.99. What is the ratio of the Emissions(kt) in Indonesia in 1980 to that in 1981?
Your answer should be compact. 0.95. What is the ratio of the Emissions(kt) of Sao Tome and Principe in 1980 to that in 1981?
Your answer should be compact. 0.92. What is the ratio of the Emissions(kt) in Latin America(developing only) in 1980 to that in 1982?
Your answer should be compact. 0.96. What is the ratio of the Emissions(kt) in Middle income in 1980 to that in 1982?
Offer a very short reply. 0.93. What is the ratio of the Emissions(kt) in Indonesia in 1980 to that in 1982?
Your response must be concise. 0.9. What is the ratio of the Emissions(kt) in Sao Tome and Principe in 1980 to that in 1982?
Provide a short and direct response. 0.85. What is the ratio of the Emissions(kt) in Latin America(developing only) in 1981 to that in 1982?
Your answer should be compact. 0.96. What is the ratio of the Emissions(kt) of Middle income in 1981 to that in 1982?
Offer a terse response. 0.94. What is the ratio of the Emissions(kt) in Indonesia in 1981 to that in 1982?
Give a very brief answer. 0.95. What is the ratio of the Emissions(kt) of Sao Tome and Principe in 1981 to that in 1982?
Your response must be concise. 0.92. What is the difference between the highest and the second highest Emissions(kt) in Latin America(developing only)?
Keep it short and to the point. 2.34e+04. What is the difference between the highest and the second highest Emissions(kt) of Middle income?
Provide a short and direct response. 3.02e+05. What is the difference between the highest and the second highest Emissions(kt) of Indonesia?
Your answer should be very brief. 5247.48. What is the difference between the highest and the second highest Emissions(kt) in Sao Tome and Principe?
Provide a short and direct response. 3.67. What is the difference between the highest and the lowest Emissions(kt) in Latin America(developing only)?
Offer a very short reply. 1.64e+05. What is the difference between the highest and the lowest Emissions(kt) in Middle income?
Keep it short and to the point. 1.16e+06. What is the difference between the highest and the lowest Emissions(kt) in Indonesia?
Give a very brief answer. 4.36e+04. What is the difference between the highest and the lowest Emissions(kt) in Sao Tome and Principe?
Ensure brevity in your answer.  18.34. 